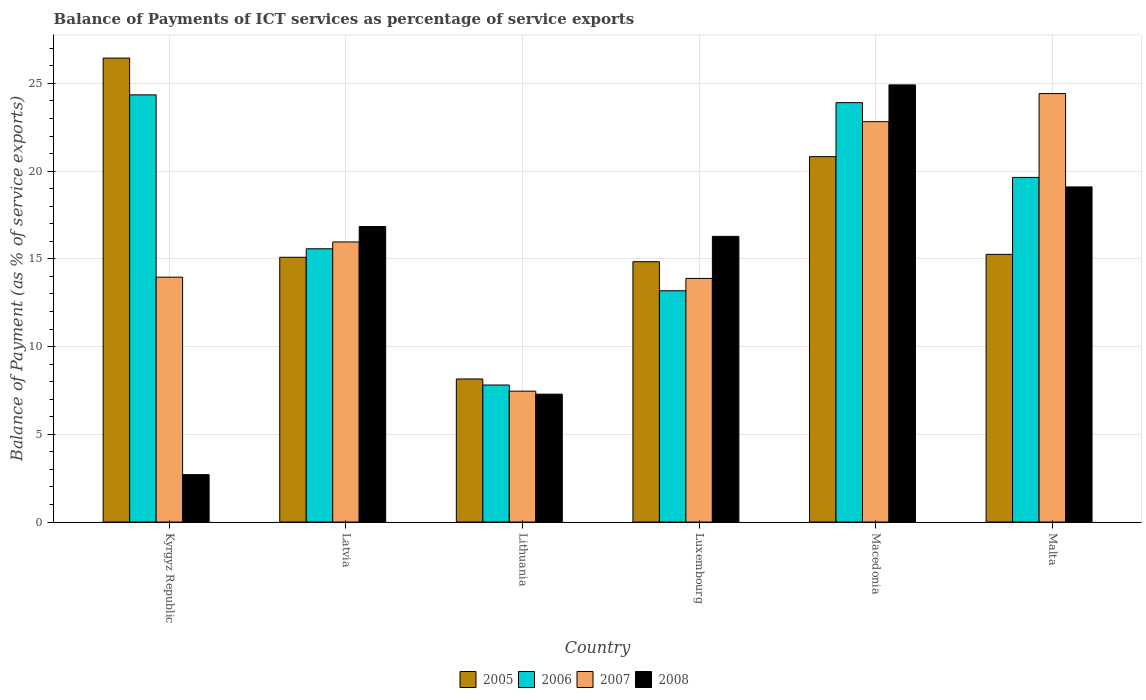How many different coloured bars are there?
Provide a succinct answer. 4. How many groups of bars are there?
Keep it short and to the point. 6. Are the number of bars per tick equal to the number of legend labels?
Your response must be concise. Yes. How many bars are there on the 2nd tick from the left?
Your answer should be compact. 4. How many bars are there on the 3rd tick from the right?
Provide a succinct answer. 4. What is the label of the 6th group of bars from the left?
Ensure brevity in your answer.  Malta. What is the balance of payments of ICT services in 2006 in Luxembourg?
Keep it short and to the point. 13.18. Across all countries, what is the maximum balance of payments of ICT services in 2005?
Offer a very short reply. 26.45. Across all countries, what is the minimum balance of payments of ICT services in 2005?
Your answer should be very brief. 8.16. In which country was the balance of payments of ICT services in 2008 maximum?
Give a very brief answer. Macedonia. In which country was the balance of payments of ICT services in 2005 minimum?
Your response must be concise. Lithuania. What is the total balance of payments of ICT services in 2006 in the graph?
Offer a very short reply. 104.47. What is the difference between the balance of payments of ICT services in 2008 in Lithuania and that in Luxembourg?
Your answer should be very brief. -8.99. What is the difference between the balance of payments of ICT services in 2008 in Kyrgyz Republic and the balance of payments of ICT services in 2005 in Luxembourg?
Offer a terse response. -12.14. What is the average balance of payments of ICT services in 2008 per country?
Your answer should be very brief. 14.52. What is the difference between the balance of payments of ICT services of/in 2007 and balance of payments of ICT services of/in 2005 in Lithuania?
Offer a very short reply. -0.7. In how many countries, is the balance of payments of ICT services in 2008 greater than 19 %?
Offer a terse response. 2. What is the ratio of the balance of payments of ICT services in 2006 in Kyrgyz Republic to that in Latvia?
Your answer should be very brief. 1.56. Is the balance of payments of ICT services in 2008 in Latvia less than that in Malta?
Your answer should be compact. Yes. What is the difference between the highest and the second highest balance of payments of ICT services in 2006?
Give a very brief answer. 4.71. What is the difference between the highest and the lowest balance of payments of ICT services in 2008?
Your response must be concise. 22.21. In how many countries, is the balance of payments of ICT services in 2008 greater than the average balance of payments of ICT services in 2008 taken over all countries?
Provide a succinct answer. 4. Is the sum of the balance of payments of ICT services in 2006 in Lithuania and Macedonia greater than the maximum balance of payments of ICT services in 2005 across all countries?
Your response must be concise. Yes. Is it the case that in every country, the sum of the balance of payments of ICT services in 2005 and balance of payments of ICT services in 2007 is greater than the sum of balance of payments of ICT services in 2006 and balance of payments of ICT services in 2008?
Your response must be concise. No. Is it the case that in every country, the sum of the balance of payments of ICT services in 2005 and balance of payments of ICT services in 2007 is greater than the balance of payments of ICT services in 2008?
Provide a succinct answer. Yes. Are all the bars in the graph horizontal?
Offer a terse response. No. What is the difference between two consecutive major ticks on the Y-axis?
Offer a very short reply. 5. Are the values on the major ticks of Y-axis written in scientific E-notation?
Provide a succinct answer. No. Does the graph contain grids?
Your answer should be compact. Yes. Where does the legend appear in the graph?
Give a very brief answer. Bottom center. What is the title of the graph?
Offer a terse response. Balance of Payments of ICT services as percentage of service exports. What is the label or title of the Y-axis?
Your answer should be very brief. Balance of Payment (as % of service exports). What is the Balance of Payment (as % of service exports) of 2005 in Kyrgyz Republic?
Keep it short and to the point. 26.45. What is the Balance of Payment (as % of service exports) of 2006 in Kyrgyz Republic?
Keep it short and to the point. 24.35. What is the Balance of Payment (as % of service exports) of 2007 in Kyrgyz Republic?
Provide a succinct answer. 13.96. What is the Balance of Payment (as % of service exports) of 2008 in Kyrgyz Republic?
Provide a succinct answer. 2.7. What is the Balance of Payment (as % of service exports) in 2005 in Latvia?
Give a very brief answer. 15.09. What is the Balance of Payment (as % of service exports) in 2006 in Latvia?
Make the answer very short. 15.58. What is the Balance of Payment (as % of service exports) of 2007 in Latvia?
Make the answer very short. 15.97. What is the Balance of Payment (as % of service exports) of 2008 in Latvia?
Provide a short and direct response. 16.84. What is the Balance of Payment (as % of service exports) of 2005 in Lithuania?
Make the answer very short. 8.16. What is the Balance of Payment (as % of service exports) in 2006 in Lithuania?
Offer a very short reply. 7.81. What is the Balance of Payment (as % of service exports) in 2007 in Lithuania?
Your answer should be compact. 7.46. What is the Balance of Payment (as % of service exports) of 2008 in Lithuania?
Give a very brief answer. 7.29. What is the Balance of Payment (as % of service exports) of 2005 in Luxembourg?
Provide a short and direct response. 14.84. What is the Balance of Payment (as % of service exports) in 2006 in Luxembourg?
Keep it short and to the point. 13.18. What is the Balance of Payment (as % of service exports) of 2007 in Luxembourg?
Provide a short and direct response. 13.89. What is the Balance of Payment (as % of service exports) in 2008 in Luxembourg?
Provide a short and direct response. 16.28. What is the Balance of Payment (as % of service exports) of 2005 in Macedonia?
Ensure brevity in your answer.  20.83. What is the Balance of Payment (as % of service exports) of 2006 in Macedonia?
Provide a short and direct response. 23.91. What is the Balance of Payment (as % of service exports) in 2007 in Macedonia?
Provide a succinct answer. 22.82. What is the Balance of Payment (as % of service exports) of 2008 in Macedonia?
Ensure brevity in your answer.  24.92. What is the Balance of Payment (as % of service exports) in 2005 in Malta?
Ensure brevity in your answer.  15.26. What is the Balance of Payment (as % of service exports) in 2006 in Malta?
Offer a terse response. 19.64. What is the Balance of Payment (as % of service exports) in 2007 in Malta?
Make the answer very short. 24.42. What is the Balance of Payment (as % of service exports) in 2008 in Malta?
Make the answer very short. 19.1. Across all countries, what is the maximum Balance of Payment (as % of service exports) in 2005?
Give a very brief answer. 26.45. Across all countries, what is the maximum Balance of Payment (as % of service exports) in 2006?
Ensure brevity in your answer.  24.35. Across all countries, what is the maximum Balance of Payment (as % of service exports) in 2007?
Your answer should be compact. 24.42. Across all countries, what is the maximum Balance of Payment (as % of service exports) of 2008?
Your response must be concise. 24.92. Across all countries, what is the minimum Balance of Payment (as % of service exports) of 2005?
Keep it short and to the point. 8.16. Across all countries, what is the minimum Balance of Payment (as % of service exports) of 2006?
Keep it short and to the point. 7.81. Across all countries, what is the minimum Balance of Payment (as % of service exports) in 2007?
Provide a short and direct response. 7.46. Across all countries, what is the minimum Balance of Payment (as % of service exports) in 2008?
Your answer should be very brief. 2.7. What is the total Balance of Payment (as % of service exports) of 2005 in the graph?
Offer a very short reply. 100.62. What is the total Balance of Payment (as % of service exports) in 2006 in the graph?
Keep it short and to the point. 104.47. What is the total Balance of Payment (as % of service exports) of 2007 in the graph?
Give a very brief answer. 98.51. What is the total Balance of Payment (as % of service exports) of 2008 in the graph?
Your answer should be very brief. 87.14. What is the difference between the Balance of Payment (as % of service exports) of 2005 in Kyrgyz Republic and that in Latvia?
Give a very brief answer. 11.35. What is the difference between the Balance of Payment (as % of service exports) in 2006 in Kyrgyz Republic and that in Latvia?
Ensure brevity in your answer.  8.77. What is the difference between the Balance of Payment (as % of service exports) of 2007 in Kyrgyz Republic and that in Latvia?
Your answer should be very brief. -2.01. What is the difference between the Balance of Payment (as % of service exports) in 2008 in Kyrgyz Republic and that in Latvia?
Offer a terse response. -14.14. What is the difference between the Balance of Payment (as % of service exports) of 2005 in Kyrgyz Republic and that in Lithuania?
Your answer should be compact. 18.29. What is the difference between the Balance of Payment (as % of service exports) in 2006 in Kyrgyz Republic and that in Lithuania?
Your answer should be very brief. 16.54. What is the difference between the Balance of Payment (as % of service exports) in 2007 in Kyrgyz Republic and that in Lithuania?
Your answer should be very brief. 6.5. What is the difference between the Balance of Payment (as % of service exports) in 2008 in Kyrgyz Republic and that in Lithuania?
Your answer should be compact. -4.59. What is the difference between the Balance of Payment (as % of service exports) of 2005 in Kyrgyz Republic and that in Luxembourg?
Give a very brief answer. 11.61. What is the difference between the Balance of Payment (as % of service exports) of 2006 in Kyrgyz Republic and that in Luxembourg?
Offer a terse response. 11.17. What is the difference between the Balance of Payment (as % of service exports) of 2007 in Kyrgyz Republic and that in Luxembourg?
Give a very brief answer. 0.07. What is the difference between the Balance of Payment (as % of service exports) of 2008 in Kyrgyz Republic and that in Luxembourg?
Offer a terse response. -13.58. What is the difference between the Balance of Payment (as % of service exports) of 2005 in Kyrgyz Republic and that in Macedonia?
Make the answer very short. 5.62. What is the difference between the Balance of Payment (as % of service exports) of 2006 in Kyrgyz Republic and that in Macedonia?
Provide a succinct answer. 0.44. What is the difference between the Balance of Payment (as % of service exports) in 2007 in Kyrgyz Republic and that in Macedonia?
Your answer should be very brief. -8.86. What is the difference between the Balance of Payment (as % of service exports) of 2008 in Kyrgyz Republic and that in Macedonia?
Make the answer very short. -22.21. What is the difference between the Balance of Payment (as % of service exports) in 2005 in Kyrgyz Republic and that in Malta?
Give a very brief answer. 11.19. What is the difference between the Balance of Payment (as % of service exports) in 2006 in Kyrgyz Republic and that in Malta?
Your answer should be compact. 4.71. What is the difference between the Balance of Payment (as % of service exports) in 2007 in Kyrgyz Republic and that in Malta?
Offer a terse response. -10.47. What is the difference between the Balance of Payment (as % of service exports) of 2008 in Kyrgyz Republic and that in Malta?
Offer a very short reply. -16.4. What is the difference between the Balance of Payment (as % of service exports) in 2005 in Latvia and that in Lithuania?
Your answer should be very brief. 6.94. What is the difference between the Balance of Payment (as % of service exports) in 2006 in Latvia and that in Lithuania?
Offer a terse response. 7.77. What is the difference between the Balance of Payment (as % of service exports) of 2007 in Latvia and that in Lithuania?
Ensure brevity in your answer.  8.51. What is the difference between the Balance of Payment (as % of service exports) in 2008 in Latvia and that in Lithuania?
Offer a very short reply. 9.55. What is the difference between the Balance of Payment (as % of service exports) of 2005 in Latvia and that in Luxembourg?
Provide a short and direct response. 0.25. What is the difference between the Balance of Payment (as % of service exports) of 2006 in Latvia and that in Luxembourg?
Keep it short and to the point. 2.39. What is the difference between the Balance of Payment (as % of service exports) in 2007 in Latvia and that in Luxembourg?
Offer a very short reply. 2.08. What is the difference between the Balance of Payment (as % of service exports) of 2008 in Latvia and that in Luxembourg?
Give a very brief answer. 0.56. What is the difference between the Balance of Payment (as % of service exports) of 2005 in Latvia and that in Macedonia?
Give a very brief answer. -5.74. What is the difference between the Balance of Payment (as % of service exports) of 2006 in Latvia and that in Macedonia?
Your response must be concise. -8.33. What is the difference between the Balance of Payment (as % of service exports) in 2007 in Latvia and that in Macedonia?
Offer a terse response. -6.86. What is the difference between the Balance of Payment (as % of service exports) in 2008 in Latvia and that in Macedonia?
Keep it short and to the point. -8.08. What is the difference between the Balance of Payment (as % of service exports) of 2005 in Latvia and that in Malta?
Give a very brief answer. -0.17. What is the difference between the Balance of Payment (as % of service exports) in 2006 in Latvia and that in Malta?
Ensure brevity in your answer.  -4.07. What is the difference between the Balance of Payment (as % of service exports) in 2007 in Latvia and that in Malta?
Your answer should be compact. -8.46. What is the difference between the Balance of Payment (as % of service exports) in 2008 in Latvia and that in Malta?
Keep it short and to the point. -2.26. What is the difference between the Balance of Payment (as % of service exports) of 2005 in Lithuania and that in Luxembourg?
Provide a succinct answer. -6.68. What is the difference between the Balance of Payment (as % of service exports) of 2006 in Lithuania and that in Luxembourg?
Make the answer very short. -5.37. What is the difference between the Balance of Payment (as % of service exports) in 2007 in Lithuania and that in Luxembourg?
Your response must be concise. -6.43. What is the difference between the Balance of Payment (as % of service exports) in 2008 in Lithuania and that in Luxembourg?
Provide a succinct answer. -8.99. What is the difference between the Balance of Payment (as % of service exports) of 2005 in Lithuania and that in Macedonia?
Keep it short and to the point. -12.67. What is the difference between the Balance of Payment (as % of service exports) in 2006 in Lithuania and that in Macedonia?
Ensure brevity in your answer.  -16.09. What is the difference between the Balance of Payment (as % of service exports) of 2007 in Lithuania and that in Macedonia?
Provide a succinct answer. -15.36. What is the difference between the Balance of Payment (as % of service exports) of 2008 in Lithuania and that in Macedonia?
Provide a short and direct response. -17.63. What is the difference between the Balance of Payment (as % of service exports) in 2005 in Lithuania and that in Malta?
Ensure brevity in your answer.  -7.1. What is the difference between the Balance of Payment (as % of service exports) in 2006 in Lithuania and that in Malta?
Provide a succinct answer. -11.83. What is the difference between the Balance of Payment (as % of service exports) of 2007 in Lithuania and that in Malta?
Provide a short and direct response. -16.96. What is the difference between the Balance of Payment (as % of service exports) of 2008 in Lithuania and that in Malta?
Offer a very short reply. -11.81. What is the difference between the Balance of Payment (as % of service exports) of 2005 in Luxembourg and that in Macedonia?
Make the answer very short. -5.99. What is the difference between the Balance of Payment (as % of service exports) in 2006 in Luxembourg and that in Macedonia?
Your answer should be compact. -10.72. What is the difference between the Balance of Payment (as % of service exports) in 2007 in Luxembourg and that in Macedonia?
Make the answer very short. -8.93. What is the difference between the Balance of Payment (as % of service exports) in 2008 in Luxembourg and that in Macedonia?
Ensure brevity in your answer.  -8.63. What is the difference between the Balance of Payment (as % of service exports) in 2005 in Luxembourg and that in Malta?
Provide a short and direct response. -0.42. What is the difference between the Balance of Payment (as % of service exports) of 2006 in Luxembourg and that in Malta?
Make the answer very short. -6.46. What is the difference between the Balance of Payment (as % of service exports) in 2007 in Luxembourg and that in Malta?
Keep it short and to the point. -10.54. What is the difference between the Balance of Payment (as % of service exports) in 2008 in Luxembourg and that in Malta?
Provide a succinct answer. -2.82. What is the difference between the Balance of Payment (as % of service exports) of 2005 in Macedonia and that in Malta?
Keep it short and to the point. 5.57. What is the difference between the Balance of Payment (as % of service exports) of 2006 in Macedonia and that in Malta?
Make the answer very short. 4.26. What is the difference between the Balance of Payment (as % of service exports) in 2007 in Macedonia and that in Malta?
Keep it short and to the point. -1.6. What is the difference between the Balance of Payment (as % of service exports) in 2008 in Macedonia and that in Malta?
Provide a succinct answer. 5.82. What is the difference between the Balance of Payment (as % of service exports) of 2005 in Kyrgyz Republic and the Balance of Payment (as % of service exports) of 2006 in Latvia?
Your answer should be very brief. 10.87. What is the difference between the Balance of Payment (as % of service exports) of 2005 in Kyrgyz Republic and the Balance of Payment (as % of service exports) of 2007 in Latvia?
Offer a very short reply. 10.48. What is the difference between the Balance of Payment (as % of service exports) of 2005 in Kyrgyz Republic and the Balance of Payment (as % of service exports) of 2008 in Latvia?
Provide a short and direct response. 9.6. What is the difference between the Balance of Payment (as % of service exports) of 2006 in Kyrgyz Republic and the Balance of Payment (as % of service exports) of 2007 in Latvia?
Provide a succinct answer. 8.38. What is the difference between the Balance of Payment (as % of service exports) of 2006 in Kyrgyz Republic and the Balance of Payment (as % of service exports) of 2008 in Latvia?
Your answer should be compact. 7.51. What is the difference between the Balance of Payment (as % of service exports) of 2007 in Kyrgyz Republic and the Balance of Payment (as % of service exports) of 2008 in Latvia?
Your response must be concise. -2.89. What is the difference between the Balance of Payment (as % of service exports) in 2005 in Kyrgyz Republic and the Balance of Payment (as % of service exports) in 2006 in Lithuania?
Give a very brief answer. 18.64. What is the difference between the Balance of Payment (as % of service exports) of 2005 in Kyrgyz Republic and the Balance of Payment (as % of service exports) of 2007 in Lithuania?
Give a very brief answer. 18.99. What is the difference between the Balance of Payment (as % of service exports) in 2005 in Kyrgyz Republic and the Balance of Payment (as % of service exports) in 2008 in Lithuania?
Make the answer very short. 19.16. What is the difference between the Balance of Payment (as % of service exports) in 2006 in Kyrgyz Republic and the Balance of Payment (as % of service exports) in 2007 in Lithuania?
Your response must be concise. 16.89. What is the difference between the Balance of Payment (as % of service exports) in 2006 in Kyrgyz Republic and the Balance of Payment (as % of service exports) in 2008 in Lithuania?
Give a very brief answer. 17.06. What is the difference between the Balance of Payment (as % of service exports) in 2007 in Kyrgyz Republic and the Balance of Payment (as % of service exports) in 2008 in Lithuania?
Offer a very short reply. 6.67. What is the difference between the Balance of Payment (as % of service exports) in 2005 in Kyrgyz Republic and the Balance of Payment (as % of service exports) in 2006 in Luxembourg?
Your answer should be compact. 13.26. What is the difference between the Balance of Payment (as % of service exports) in 2005 in Kyrgyz Republic and the Balance of Payment (as % of service exports) in 2007 in Luxembourg?
Provide a succinct answer. 12.56. What is the difference between the Balance of Payment (as % of service exports) in 2005 in Kyrgyz Republic and the Balance of Payment (as % of service exports) in 2008 in Luxembourg?
Offer a very short reply. 10.16. What is the difference between the Balance of Payment (as % of service exports) of 2006 in Kyrgyz Republic and the Balance of Payment (as % of service exports) of 2007 in Luxembourg?
Make the answer very short. 10.46. What is the difference between the Balance of Payment (as % of service exports) in 2006 in Kyrgyz Republic and the Balance of Payment (as % of service exports) in 2008 in Luxembourg?
Your answer should be very brief. 8.07. What is the difference between the Balance of Payment (as % of service exports) of 2007 in Kyrgyz Republic and the Balance of Payment (as % of service exports) of 2008 in Luxembourg?
Your response must be concise. -2.33. What is the difference between the Balance of Payment (as % of service exports) of 2005 in Kyrgyz Republic and the Balance of Payment (as % of service exports) of 2006 in Macedonia?
Make the answer very short. 2.54. What is the difference between the Balance of Payment (as % of service exports) in 2005 in Kyrgyz Republic and the Balance of Payment (as % of service exports) in 2007 in Macedonia?
Keep it short and to the point. 3.62. What is the difference between the Balance of Payment (as % of service exports) in 2005 in Kyrgyz Republic and the Balance of Payment (as % of service exports) in 2008 in Macedonia?
Your answer should be very brief. 1.53. What is the difference between the Balance of Payment (as % of service exports) in 2006 in Kyrgyz Republic and the Balance of Payment (as % of service exports) in 2007 in Macedonia?
Keep it short and to the point. 1.53. What is the difference between the Balance of Payment (as % of service exports) in 2006 in Kyrgyz Republic and the Balance of Payment (as % of service exports) in 2008 in Macedonia?
Provide a succinct answer. -0.57. What is the difference between the Balance of Payment (as % of service exports) in 2007 in Kyrgyz Republic and the Balance of Payment (as % of service exports) in 2008 in Macedonia?
Your response must be concise. -10.96. What is the difference between the Balance of Payment (as % of service exports) in 2005 in Kyrgyz Republic and the Balance of Payment (as % of service exports) in 2006 in Malta?
Provide a succinct answer. 6.8. What is the difference between the Balance of Payment (as % of service exports) in 2005 in Kyrgyz Republic and the Balance of Payment (as % of service exports) in 2007 in Malta?
Your answer should be very brief. 2.02. What is the difference between the Balance of Payment (as % of service exports) of 2005 in Kyrgyz Republic and the Balance of Payment (as % of service exports) of 2008 in Malta?
Your response must be concise. 7.34. What is the difference between the Balance of Payment (as % of service exports) of 2006 in Kyrgyz Republic and the Balance of Payment (as % of service exports) of 2007 in Malta?
Keep it short and to the point. -0.07. What is the difference between the Balance of Payment (as % of service exports) of 2006 in Kyrgyz Republic and the Balance of Payment (as % of service exports) of 2008 in Malta?
Keep it short and to the point. 5.25. What is the difference between the Balance of Payment (as % of service exports) in 2007 in Kyrgyz Republic and the Balance of Payment (as % of service exports) in 2008 in Malta?
Give a very brief answer. -5.14. What is the difference between the Balance of Payment (as % of service exports) in 2005 in Latvia and the Balance of Payment (as % of service exports) in 2006 in Lithuania?
Your answer should be compact. 7.28. What is the difference between the Balance of Payment (as % of service exports) of 2005 in Latvia and the Balance of Payment (as % of service exports) of 2007 in Lithuania?
Provide a succinct answer. 7.63. What is the difference between the Balance of Payment (as % of service exports) in 2005 in Latvia and the Balance of Payment (as % of service exports) in 2008 in Lithuania?
Your answer should be very brief. 7.8. What is the difference between the Balance of Payment (as % of service exports) of 2006 in Latvia and the Balance of Payment (as % of service exports) of 2007 in Lithuania?
Offer a terse response. 8.12. What is the difference between the Balance of Payment (as % of service exports) in 2006 in Latvia and the Balance of Payment (as % of service exports) in 2008 in Lithuania?
Give a very brief answer. 8.29. What is the difference between the Balance of Payment (as % of service exports) of 2007 in Latvia and the Balance of Payment (as % of service exports) of 2008 in Lithuania?
Your answer should be compact. 8.68. What is the difference between the Balance of Payment (as % of service exports) in 2005 in Latvia and the Balance of Payment (as % of service exports) in 2006 in Luxembourg?
Keep it short and to the point. 1.91. What is the difference between the Balance of Payment (as % of service exports) in 2005 in Latvia and the Balance of Payment (as % of service exports) in 2007 in Luxembourg?
Provide a succinct answer. 1.2. What is the difference between the Balance of Payment (as % of service exports) of 2005 in Latvia and the Balance of Payment (as % of service exports) of 2008 in Luxembourg?
Your answer should be compact. -1.19. What is the difference between the Balance of Payment (as % of service exports) in 2006 in Latvia and the Balance of Payment (as % of service exports) in 2007 in Luxembourg?
Your response must be concise. 1.69. What is the difference between the Balance of Payment (as % of service exports) in 2006 in Latvia and the Balance of Payment (as % of service exports) in 2008 in Luxembourg?
Provide a succinct answer. -0.71. What is the difference between the Balance of Payment (as % of service exports) of 2007 in Latvia and the Balance of Payment (as % of service exports) of 2008 in Luxembourg?
Your answer should be compact. -0.32. What is the difference between the Balance of Payment (as % of service exports) in 2005 in Latvia and the Balance of Payment (as % of service exports) in 2006 in Macedonia?
Keep it short and to the point. -8.81. What is the difference between the Balance of Payment (as % of service exports) in 2005 in Latvia and the Balance of Payment (as % of service exports) in 2007 in Macedonia?
Your answer should be very brief. -7.73. What is the difference between the Balance of Payment (as % of service exports) in 2005 in Latvia and the Balance of Payment (as % of service exports) in 2008 in Macedonia?
Offer a terse response. -9.83. What is the difference between the Balance of Payment (as % of service exports) in 2006 in Latvia and the Balance of Payment (as % of service exports) in 2007 in Macedonia?
Offer a terse response. -7.24. What is the difference between the Balance of Payment (as % of service exports) of 2006 in Latvia and the Balance of Payment (as % of service exports) of 2008 in Macedonia?
Provide a short and direct response. -9.34. What is the difference between the Balance of Payment (as % of service exports) of 2007 in Latvia and the Balance of Payment (as % of service exports) of 2008 in Macedonia?
Ensure brevity in your answer.  -8.95. What is the difference between the Balance of Payment (as % of service exports) in 2005 in Latvia and the Balance of Payment (as % of service exports) in 2006 in Malta?
Keep it short and to the point. -4.55. What is the difference between the Balance of Payment (as % of service exports) in 2005 in Latvia and the Balance of Payment (as % of service exports) in 2007 in Malta?
Provide a short and direct response. -9.33. What is the difference between the Balance of Payment (as % of service exports) of 2005 in Latvia and the Balance of Payment (as % of service exports) of 2008 in Malta?
Your response must be concise. -4.01. What is the difference between the Balance of Payment (as % of service exports) in 2006 in Latvia and the Balance of Payment (as % of service exports) in 2007 in Malta?
Offer a very short reply. -8.85. What is the difference between the Balance of Payment (as % of service exports) in 2006 in Latvia and the Balance of Payment (as % of service exports) in 2008 in Malta?
Keep it short and to the point. -3.53. What is the difference between the Balance of Payment (as % of service exports) in 2007 in Latvia and the Balance of Payment (as % of service exports) in 2008 in Malta?
Give a very brief answer. -3.14. What is the difference between the Balance of Payment (as % of service exports) of 2005 in Lithuania and the Balance of Payment (as % of service exports) of 2006 in Luxembourg?
Provide a succinct answer. -5.03. What is the difference between the Balance of Payment (as % of service exports) in 2005 in Lithuania and the Balance of Payment (as % of service exports) in 2007 in Luxembourg?
Give a very brief answer. -5.73. What is the difference between the Balance of Payment (as % of service exports) of 2005 in Lithuania and the Balance of Payment (as % of service exports) of 2008 in Luxembourg?
Keep it short and to the point. -8.13. What is the difference between the Balance of Payment (as % of service exports) in 2006 in Lithuania and the Balance of Payment (as % of service exports) in 2007 in Luxembourg?
Offer a very short reply. -6.08. What is the difference between the Balance of Payment (as % of service exports) of 2006 in Lithuania and the Balance of Payment (as % of service exports) of 2008 in Luxembourg?
Make the answer very short. -8.47. What is the difference between the Balance of Payment (as % of service exports) in 2007 in Lithuania and the Balance of Payment (as % of service exports) in 2008 in Luxembourg?
Ensure brevity in your answer.  -8.82. What is the difference between the Balance of Payment (as % of service exports) in 2005 in Lithuania and the Balance of Payment (as % of service exports) in 2006 in Macedonia?
Give a very brief answer. -15.75. What is the difference between the Balance of Payment (as % of service exports) in 2005 in Lithuania and the Balance of Payment (as % of service exports) in 2007 in Macedonia?
Your answer should be very brief. -14.67. What is the difference between the Balance of Payment (as % of service exports) of 2005 in Lithuania and the Balance of Payment (as % of service exports) of 2008 in Macedonia?
Offer a very short reply. -16.76. What is the difference between the Balance of Payment (as % of service exports) of 2006 in Lithuania and the Balance of Payment (as % of service exports) of 2007 in Macedonia?
Make the answer very short. -15.01. What is the difference between the Balance of Payment (as % of service exports) in 2006 in Lithuania and the Balance of Payment (as % of service exports) in 2008 in Macedonia?
Your answer should be compact. -17.11. What is the difference between the Balance of Payment (as % of service exports) in 2007 in Lithuania and the Balance of Payment (as % of service exports) in 2008 in Macedonia?
Provide a succinct answer. -17.46. What is the difference between the Balance of Payment (as % of service exports) in 2005 in Lithuania and the Balance of Payment (as % of service exports) in 2006 in Malta?
Give a very brief answer. -11.49. What is the difference between the Balance of Payment (as % of service exports) of 2005 in Lithuania and the Balance of Payment (as % of service exports) of 2007 in Malta?
Offer a terse response. -16.27. What is the difference between the Balance of Payment (as % of service exports) of 2005 in Lithuania and the Balance of Payment (as % of service exports) of 2008 in Malta?
Your answer should be very brief. -10.95. What is the difference between the Balance of Payment (as % of service exports) in 2006 in Lithuania and the Balance of Payment (as % of service exports) in 2007 in Malta?
Give a very brief answer. -16.61. What is the difference between the Balance of Payment (as % of service exports) in 2006 in Lithuania and the Balance of Payment (as % of service exports) in 2008 in Malta?
Provide a short and direct response. -11.29. What is the difference between the Balance of Payment (as % of service exports) of 2007 in Lithuania and the Balance of Payment (as % of service exports) of 2008 in Malta?
Provide a short and direct response. -11.64. What is the difference between the Balance of Payment (as % of service exports) of 2005 in Luxembourg and the Balance of Payment (as % of service exports) of 2006 in Macedonia?
Offer a terse response. -9.07. What is the difference between the Balance of Payment (as % of service exports) in 2005 in Luxembourg and the Balance of Payment (as % of service exports) in 2007 in Macedonia?
Offer a very short reply. -7.98. What is the difference between the Balance of Payment (as % of service exports) in 2005 in Luxembourg and the Balance of Payment (as % of service exports) in 2008 in Macedonia?
Your answer should be very brief. -10.08. What is the difference between the Balance of Payment (as % of service exports) in 2006 in Luxembourg and the Balance of Payment (as % of service exports) in 2007 in Macedonia?
Your answer should be compact. -9.64. What is the difference between the Balance of Payment (as % of service exports) in 2006 in Luxembourg and the Balance of Payment (as % of service exports) in 2008 in Macedonia?
Keep it short and to the point. -11.74. What is the difference between the Balance of Payment (as % of service exports) of 2007 in Luxembourg and the Balance of Payment (as % of service exports) of 2008 in Macedonia?
Offer a very short reply. -11.03. What is the difference between the Balance of Payment (as % of service exports) in 2005 in Luxembourg and the Balance of Payment (as % of service exports) in 2006 in Malta?
Provide a succinct answer. -4.8. What is the difference between the Balance of Payment (as % of service exports) in 2005 in Luxembourg and the Balance of Payment (as % of service exports) in 2007 in Malta?
Offer a very short reply. -9.58. What is the difference between the Balance of Payment (as % of service exports) in 2005 in Luxembourg and the Balance of Payment (as % of service exports) in 2008 in Malta?
Ensure brevity in your answer.  -4.26. What is the difference between the Balance of Payment (as % of service exports) of 2006 in Luxembourg and the Balance of Payment (as % of service exports) of 2007 in Malta?
Offer a terse response. -11.24. What is the difference between the Balance of Payment (as % of service exports) of 2006 in Luxembourg and the Balance of Payment (as % of service exports) of 2008 in Malta?
Your response must be concise. -5.92. What is the difference between the Balance of Payment (as % of service exports) of 2007 in Luxembourg and the Balance of Payment (as % of service exports) of 2008 in Malta?
Your response must be concise. -5.21. What is the difference between the Balance of Payment (as % of service exports) in 2005 in Macedonia and the Balance of Payment (as % of service exports) in 2006 in Malta?
Make the answer very short. 1.18. What is the difference between the Balance of Payment (as % of service exports) in 2005 in Macedonia and the Balance of Payment (as % of service exports) in 2007 in Malta?
Offer a terse response. -3.59. What is the difference between the Balance of Payment (as % of service exports) of 2005 in Macedonia and the Balance of Payment (as % of service exports) of 2008 in Malta?
Make the answer very short. 1.73. What is the difference between the Balance of Payment (as % of service exports) in 2006 in Macedonia and the Balance of Payment (as % of service exports) in 2007 in Malta?
Ensure brevity in your answer.  -0.52. What is the difference between the Balance of Payment (as % of service exports) of 2006 in Macedonia and the Balance of Payment (as % of service exports) of 2008 in Malta?
Make the answer very short. 4.8. What is the difference between the Balance of Payment (as % of service exports) in 2007 in Macedonia and the Balance of Payment (as % of service exports) in 2008 in Malta?
Give a very brief answer. 3.72. What is the average Balance of Payment (as % of service exports) in 2005 per country?
Offer a very short reply. 16.77. What is the average Balance of Payment (as % of service exports) in 2006 per country?
Make the answer very short. 17.41. What is the average Balance of Payment (as % of service exports) of 2007 per country?
Offer a very short reply. 16.42. What is the average Balance of Payment (as % of service exports) in 2008 per country?
Your response must be concise. 14.52. What is the difference between the Balance of Payment (as % of service exports) of 2005 and Balance of Payment (as % of service exports) of 2006 in Kyrgyz Republic?
Offer a very short reply. 2.1. What is the difference between the Balance of Payment (as % of service exports) of 2005 and Balance of Payment (as % of service exports) of 2007 in Kyrgyz Republic?
Give a very brief answer. 12.49. What is the difference between the Balance of Payment (as % of service exports) in 2005 and Balance of Payment (as % of service exports) in 2008 in Kyrgyz Republic?
Offer a very short reply. 23.74. What is the difference between the Balance of Payment (as % of service exports) in 2006 and Balance of Payment (as % of service exports) in 2007 in Kyrgyz Republic?
Offer a terse response. 10.39. What is the difference between the Balance of Payment (as % of service exports) in 2006 and Balance of Payment (as % of service exports) in 2008 in Kyrgyz Republic?
Make the answer very short. 21.65. What is the difference between the Balance of Payment (as % of service exports) of 2007 and Balance of Payment (as % of service exports) of 2008 in Kyrgyz Republic?
Provide a succinct answer. 11.25. What is the difference between the Balance of Payment (as % of service exports) in 2005 and Balance of Payment (as % of service exports) in 2006 in Latvia?
Your answer should be very brief. -0.48. What is the difference between the Balance of Payment (as % of service exports) of 2005 and Balance of Payment (as % of service exports) of 2007 in Latvia?
Offer a very short reply. -0.87. What is the difference between the Balance of Payment (as % of service exports) in 2005 and Balance of Payment (as % of service exports) in 2008 in Latvia?
Make the answer very short. -1.75. What is the difference between the Balance of Payment (as % of service exports) in 2006 and Balance of Payment (as % of service exports) in 2007 in Latvia?
Give a very brief answer. -0.39. What is the difference between the Balance of Payment (as % of service exports) in 2006 and Balance of Payment (as % of service exports) in 2008 in Latvia?
Ensure brevity in your answer.  -1.27. What is the difference between the Balance of Payment (as % of service exports) in 2007 and Balance of Payment (as % of service exports) in 2008 in Latvia?
Make the answer very short. -0.88. What is the difference between the Balance of Payment (as % of service exports) in 2005 and Balance of Payment (as % of service exports) in 2006 in Lithuania?
Offer a very short reply. 0.34. What is the difference between the Balance of Payment (as % of service exports) of 2005 and Balance of Payment (as % of service exports) of 2007 in Lithuania?
Your answer should be compact. 0.7. What is the difference between the Balance of Payment (as % of service exports) of 2005 and Balance of Payment (as % of service exports) of 2008 in Lithuania?
Your response must be concise. 0.87. What is the difference between the Balance of Payment (as % of service exports) of 2006 and Balance of Payment (as % of service exports) of 2007 in Lithuania?
Your answer should be very brief. 0.35. What is the difference between the Balance of Payment (as % of service exports) in 2006 and Balance of Payment (as % of service exports) in 2008 in Lithuania?
Your response must be concise. 0.52. What is the difference between the Balance of Payment (as % of service exports) of 2007 and Balance of Payment (as % of service exports) of 2008 in Lithuania?
Your answer should be very brief. 0.17. What is the difference between the Balance of Payment (as % of service exports) of 2005 and Balance of Payment (as % of service exports) of 2006 in Luxembourg?
Ensure brevity in your answer.  1.66. What is the difference between the Balance of Payment (as % of service exports) in 2005 and Balance of Payment (as % of service exports) in 2007 in Luxembourg?
Make the answer very short. 0.95. What is the difference between the Balance of Payment (as % of service exports) of 2005 and Balance of Payment (as % of service exports) of 2008 in Luxembourg?
Your answer should be very brief. -1.44. What is the difference between the Balance of Payment (as % of service exports) of 2006 and Balance of Payment (as % of service exports) of 2007 in Luxembourg?
Give a very brief answer. -0.7. What is the difference between the Balance of Payment (as % of service exports) of 2006 and Balance of Payment (as % of service exports) of 2008 in Luxembourg?
Provide a succinct answer. -3.1. What is the difference between the Balance of Payment (as % of service exports) of 2007 and Balance of Payment (as % of service exports) of 2008 in Luxembourg?
Make the answer very short. -2.4. What is the difference between the Balance of Payment (as % of service exports) of 2005 and Balance of Payment (as % of service exports) of 2006 in Macedonia?
Keep it short and to the point. -3.08. What is the difference between the Balance of Payment (as % of service exports) of 2005 and Balance of Payment (as % of service exports) of 2007 in Macedonia?
Offer a terse response. -1.99. What is the difference between the Balance of Payment (as % of service exports) in 2005 and Balance of Payment (as % of service exports) in 2008 in Macedonia?
Ensure brevity in your answer.  -4.09. What is the difference between the Balance of Payment (as % of service exports) of 2006 and Balance of Payment (as % of service exports) of 2007 in Macedonia?
Provide a succinct answer. 1.08. What is the difference between the Balance of Payment (as % of service exports) in 2006 and Balance of Payment (as % of service exports) in 2008 in Macedonia?
Provide a succinct answer. -1.01. What is the difference between the Balance of Payment (as % of service exports) of 2007 and Balance of Payment (as % of service exports) of 2008 in Macedonia?
Offer a terse response. -2.1. What is the difference between the Balance of Payment (as % of service exports) of 2005 and Balance of Payment (as % of service exports) of 2006 in Malta?
Make the answer very short. -4.39. What is the difference between the Balance of Payment (as % of service exports) in 2005 and Balance of Payment (as % of service exports) in 2007 in Malta?
Your answer should be compact. -9.16. What is the difference between the Balance of Payment (as % of service exports) in 2005 and Balance of Payment (as % of service exports) in 2008 in Malta?
Give a very brief answer. -3.84. What is the difference between the Balance of Payment (as % of service exports) in 2006 and Balance of Payment (as % of service exports) in 2007 in Malta?
Offer a very short reply. -4.78. What is the difference between the Balance of Payment (as % of service exports) in 2006 and Balance of Payment (as % of service exports) in 2008 in Malta?
Your response must be concise. 0.54. What is the difference between the Balance of Payment (as % of service exports) in 2007 and Balance of Payment (as % of service exports) in 2008 in Malta?
Provide a short and direct response. 5.32. What is the ratio of the Balance of Payment (as % of service exports) in 2005 in Kyrgyz Republic to that in Latvia?
Your response must be concise. 1.75. What is the ratio of the Balance of Payment (as % of service exports) of 2006 in Kyrgyz Republic to that in Latvia?
Provide a succinct answer. 1.56. What is the ratio of the Balance of Payment (as % of service exports) of 2007 in Kyrgyz Republic to that in Latvia?
Your response must be concise. 0.87. What is the ratio of the Balance of Payment (as % of service exports) in 2008 in Kyrgyz Republic to that in Latvia?
Offer a very short reply. 0.16. What is the ratio of the Balance of Payment (as % of service exports) in 2005 in Kyrgyz Republic to that in Lithuania?
Your answer should be very brief. 3.24. What is the ratio of the Balance of Payment (as % of service exports) of 2006 in Kyrgyz Republic to that in Lithuania?
Provide a succinct answer. 3.12. What is the ratio of the Balance of Payment (as % of service exports) in 2007 in Kyrgyz Republic to that in Lithuania?
Offer a terse response. 1.87. What is the ratio of the Balance of Payment (as % of service exports) in 2008 in Kyrgyz Republic to that in Lithuania?
Offer a terse response. 0.37. What is the ratio of the Balance of Payment (as % of service exports) of 2005 in Kyrgyz Republic to that in Luxembourg?
Keep it short and to the point. 1.78. What is the ratio of the Balance of Payment (as % of service exports) in 2006 in Kyrgyz Republic to that in Luxembourg?
Offer a very short reply. 1.85. What is the ratio of the Balance of Payment (as % of service exports) in 2007 in Kyrgyz Republic to that in Luxembourg?
Your response must be concise. 1. What is the ratio of the Balance of Payment (as % of service exports) in 2008 in Kyrgyz Republic to that in Luxembourg?
Ensure brevity in your answer.  0.17. What is the ratio of the Balance of Payment (as % of service exports) of 2005 in Kyrgyz Republic to that in Macedonia?
Provide a short and direct response. 1.27. What is the ratio of the Balance of Payment (as % of service exports) of 2006 in Kyrgyz Republic to that in Macedonia?
Ensure brevity in your answer.  1.02. What is the ratio of the Balance of Payment (as % of service exports) in 2007 in Kyrgyz Republic to that in Macedonia?
Your answer should be compact. 0.61. What is the ratio of the Balance of Payment (as % of service exports) in 2008 in Kyrgyz Republic to that in Macedonia?
Your answer should be very brief. 0.11. What is the ratio of the Balance of Payment (as % of service exports) in 2005 in Kyrgyz Republic to that in Malta?
Provide a short and direct response. 1.73. What is the ratio of the Balance of Payment (as % of service exports) of 2006 in Kyrgyz Republic to that in Malta?
Your answer should be very brief. 1.24. What is the ratio of the Balance of Payment (as % of service exports) in 2007 in Kyrgyz Republic to that in Malta?
Your answer should be compact. 0.57. What is the ratio of the Balance of Payment (as % of service exports) of 2008 in Kyrgyz Republic to that in Malta?
Provide a short and direct response. 0.14. What is the ratio of the Balance of Payment (as % of service exports) of 2005 in Latvia to that in Lithuania?
Keep it short and to the point. 1.85. What is the ratio of the Balance of Payment (as % of service exports) in 2006 in Latvia to that in Lithuania?
Provide a short and direct response. 1.99. What is the ratio of the Balance of Payment (as % of service exports) in 2007 in Latvia to that in Lithuania?
Keep it short and to the point. 2.14. What is the ratio of the Balance of Payment (as % of service exports) of 2008 in Latvia to that in Lithuania?
Keep it short and to the point. 2.31. What is the ratio of the Balance of Payment (as % of service exports) of 2006 in Latvia to that in Luxembourg?
Keep it short and to the point. 1.18. What is the ratio of the Balance of Payment (as % of service exports) in 2007 in Latvia to that in Luxembourg?
Your response must be concise. 1.15. What is the ratio of the Balance of Payment (as % of service exports) of 2008 in Latvia to that in Luxembourg?
Your answer should be very brief. 1.03. What is the ratio of the Balance of Payment (as % of service exports) in 2005 in Latvia to that in Macedonia?
Give a very brief answer. 0.72. What is the ratio of the Balance of Payment (as % of service exports) in 2006 in Latvia to that in Macedonia?
Make the answer very short. 0.65. What is the ratio of the Balance of Payment (as % of service exports) of 2007 in Latvia to that in Macedonia?
Your answer should be very brief. 0.7. What is the ratio of the Balance of Payment (as % of service exports) of 2008 in Latvia to that in Macedonia?
Provide a succinct answer. 0.68. What is the ratio of the Balance of Payment (as % of service exports) of 2005 in Latvia to that in Malta?
Provide a succinct answer. 0.99. What is the ratio of the Balance of Payment (as % of service exports) of 2006 in Latvia to that in Malta?
Offer a very short reply. 0.79. What is the ratio of the Balance of Payment (as % of service exports) in 2007 in Latvia to that in Malta?
Your response must be concise. 0.65. What is the ratio of the Balance of Payment (as % of service exports) of 2008 in Latvia to that in Malta?
Ensure brevity in your answer.  0.88. What is the ratio of the Balance of Payment (as % of service exports) in 2005 in Lithuania to that in Luxembourg?
Offer a very short reply. 0.55. What is the ratio of the Balance of Payment (as % of service exports) of 2006 in Lithuania to that in Luxembourg?
Offer a terse response. 0.59. What is the ratio of the Balance of Payment (as % of service exports) of 2007 in Lithuania to that in Luxembourg?
Your answer should be very brief. 0.54. What is the ratio of the Balance of Payment (as % of service exports) of 2008 in Lithuania to that in Luxembourg?
Offer a terse response. 0.45. What is the ratio of the Balance of Payment (as % of service exports) in 2005 in Lithuania to that in Macedonia?
Give a very brief answer. 0.39. What is the ratio of the Balance of Payment (as % of service exports) in 2006 in Lithuania to that in Macedonia?
Offer a terse response. 0.33. What is the ratio of the Balance of Payment (as % of service exports) of 2007 in Lithuania to that in Macedonia?
Ensure brevity in your answer.  0.33. What is the ratio of the Balance of Payment (as % of service exports) in 2008 in Lithuania to that in Macedonia?
Offer a very short reply. 0.29. What is the ratio of the Balance of Payment (as % of service exports) of 2005 in Lithuania to that in Malta?
Your answer should be compact. 0.53. What is the ratio of the Balance of Payment (as % of service exports) of 2006 in Lithuania to that in Malta?
Provide a succinct answer. 0.4. What is the ratio of the Balance of Payment (as % of service exports) in 2007 in Lithuania to that in Malta?
Give a very brief answer. 0.31. What is the ratio of the Balance of Payment (as % of service exports) of 2008 in Lithuania to that in Malta?
Offer a very short reply. 0.38. What is the ratio of the Balance of Payment (as % of service exports) of 2005 in Luxembourg to that in Macedonia?
Offer a terse response. 0.71. What is the ratio of the Balance of Payment (as % of service exports) of 2006 in Luxembourg to that in Macedonia?
Give a very brief answer. 0.55. What is the ratio of the Balance of Payment (as % of service exports) in 2007 in Luxembourg to that in Macedonia?
Your answer should be very brief. 0.61. What is the ratio of the Balance of Payment (as % of service exports) of 2008 in Luxembourg to that in Macedonia?
Offer a very short reply. 0.65. What is the ratio of the Balance of Payment (as % of service exports) of 2005 in Luxembourg to that in Malta?
Give a very brief answer. 0.97. What is the ratio of the Balance of Payment (as % of service exports) of 2006 in Luxembourg to that in Malta?
Provide a succinct answer. 0.67. What is the ratio of the Balance of Payment (as % of service exports) in 2007 in Luxembourg to that in Malta?
Offer a terse response. 0.57. What is the ratio of the Balance of Payment (as % of service exports) in 2008 in Luxembourg to that in Malta?
Provide a succinct answer. 0.85. What is the ratio of the Balance of Payment (as % of service exports) in 2005 in Macedonia to that in Malta?
Offer a very short reply. 1.36. What is the ratio of the Balance of Payment (as % of service exports) in 2006 in Macedonia to that in Malta?
Give a very brief answer. 1.22. What is the ratio of the Balance of Payment (as % of service exports) in 2007 in Macedonia to that in Malta?
Your answer should be compact. 0.93. What is the ratio of the Balance of Payment (as % of service exports) of 2008 in Macedonia to that in Malta?
Provide a succinct answer. 1.3. What is the difference between the highest and the second highest Balance of Payment (as % of service exports) of 2005?
Your response must be concise. 5.62. What is the difference between the highest and the second highest Balance of Payment (as % of service exports) in 2006?
Offer a terse response. 0.44. What is the difference between the highest and the second highest Balance of Payment (as % of service exports) in 2007?
Ensure brevity in your answer.  1.6. What is the difference between the highest and the second highest Balance of Payment (as % of service exports) in 2008?
Provide a short and direct response. 5.82. What is the difference between the highest and the lowest Balance of Payment (as % of service exports) in 2005?
Ensure brevity in your answer.  18.29. What is the difference between the highest and the lowest Balance of Payment (as % of service exports) of 2006?
Provide a short and direct response. 16.54. What is the difference between the highest and the lowest Balance of Payment (as % of service exports) in 2007?
Make the answer very short. 16.96. What is the difference between the highest and the lowest Balance of Payment (as % of service exports) of 2008?
Offer a terse response. 22.21. 